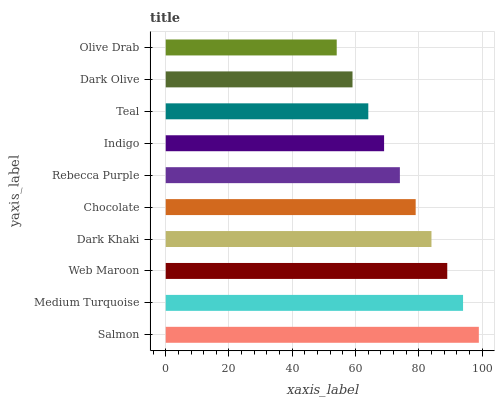Is Olive Drab the minimum?
Answer yes or no. Yes. Is Salmon the maximum?
Answer yes or no. Yes. Is Medium Turquoise the minimum?
Answer yes or no. No. Is Medium Turquoise the maximum?
Answer yes or no. No. Is Salmon greater than Medium Turquoise?
Answer yes or no. Yes. Is Medium Turquoise less than Salmon?
Answer yes or no. Yes. Is Medium Turquoise greater than Salmon?
Answer yes or no. No. Is Salmon less than Medium Turquoise?
Answer yes or no. No. Is Chocolate the high median?
Answer yes or no. Yes. Is Rebecca Purple the low median?
Answer yes or no. Yes. Is Rebecca Purple the high median?
Answer yes or no. No. Is Chocolate the low median?
Answer yes or no. No. 